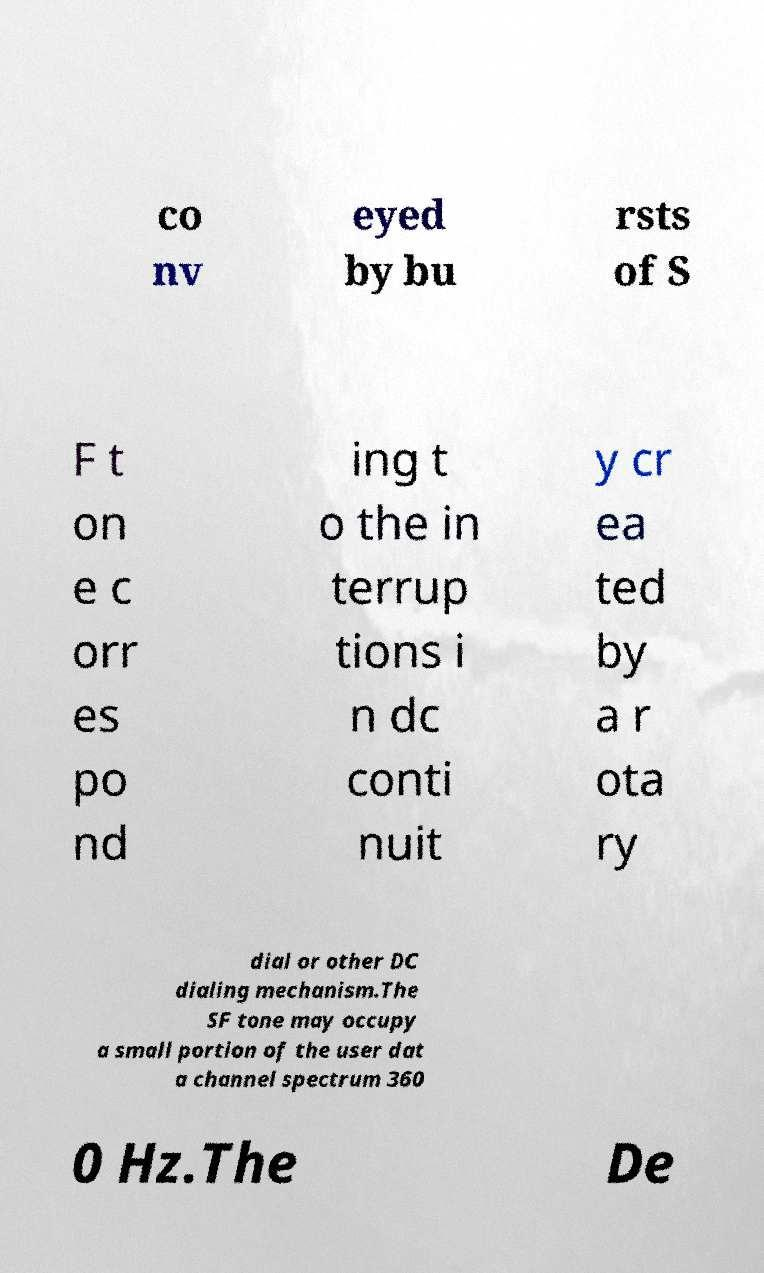Please read and relay the text visible in this image. What does it say? co nv eyed by bu rsts of S F t on e c orr es po nd ing t o the in terrup tions i n dc conti nuit y cr ea ted by a r ota ry dial or other DC dialing mechanism.The SF tone may occupy a small portion of the user dat a channel spectrum 360 0 Hz.The De 